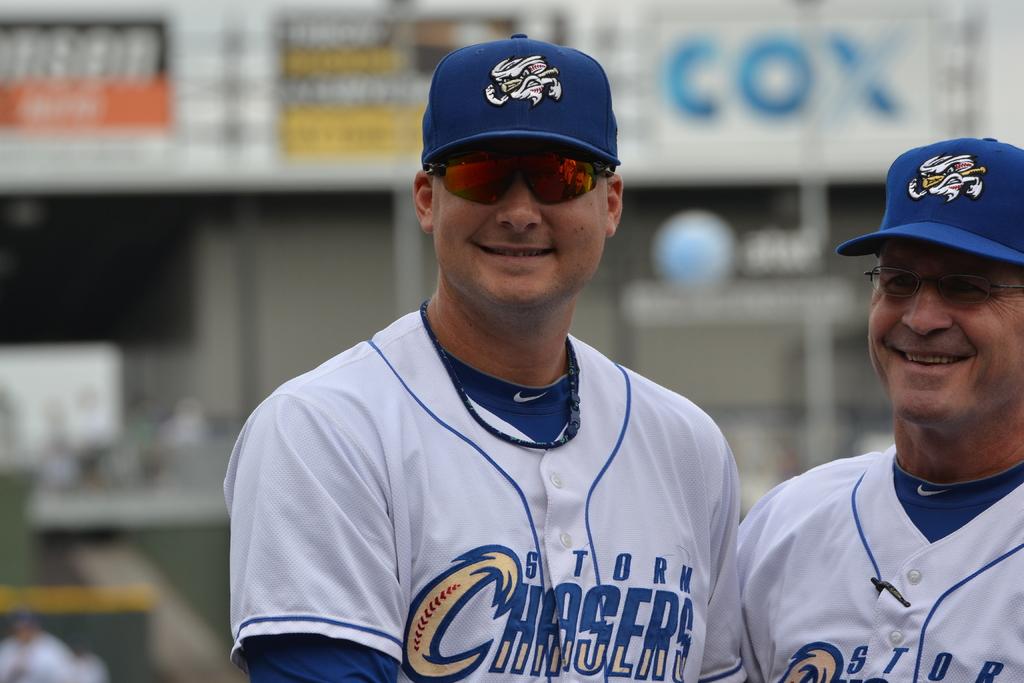What is the team name on the player's jerseys?
Your response must be concise. Storm chasers. What cable brand is shown in background?
Ensure brevity in your answer.  Cox. 